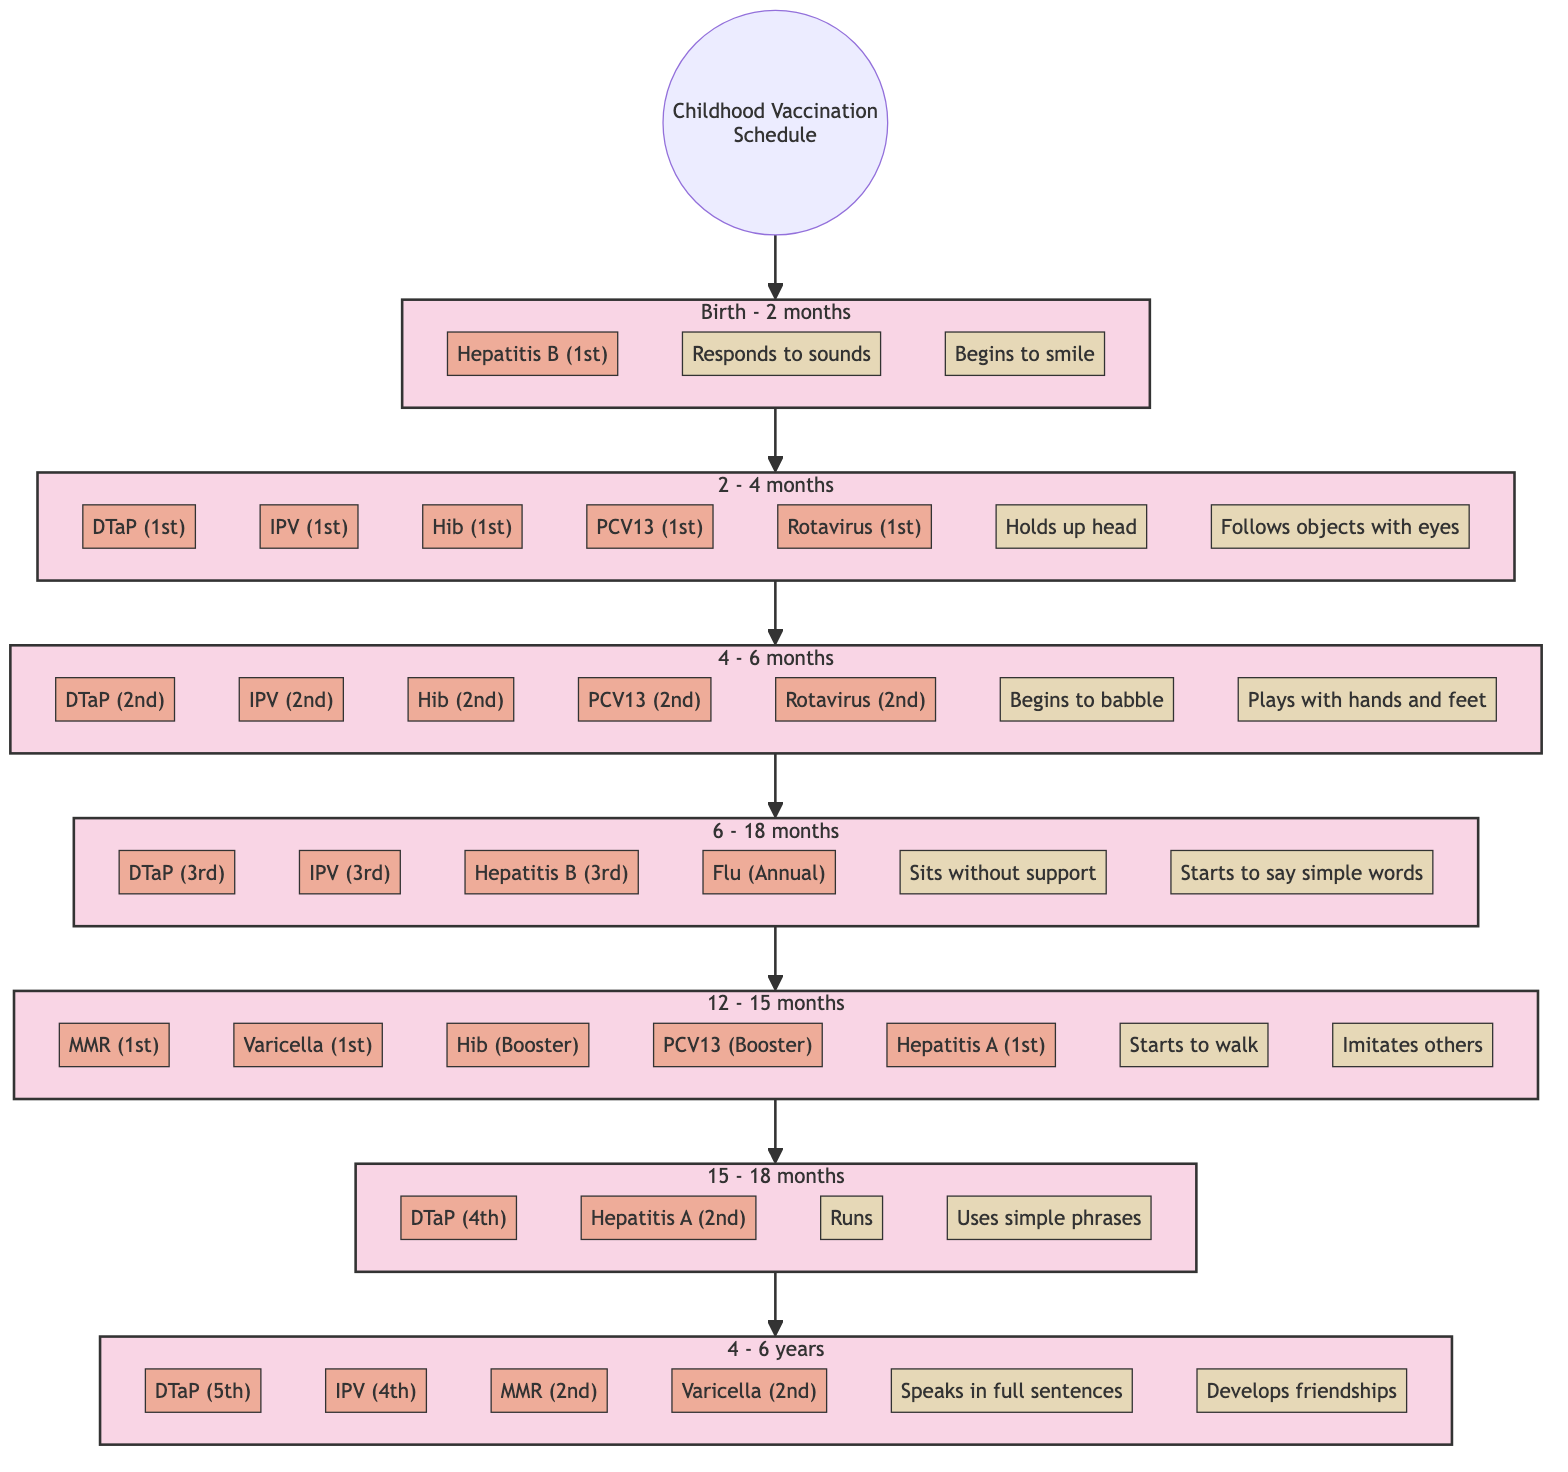What's the first vaccination listed for the age range Birth - 2 months? The diagram shows the "Hepatitis B" vaccination as the first vaccination under the age range Birth - 2 months.
Answer: Hepatitis B How many vaccinations are listed for the 2 months - 4 months age range? In the diagram, there are five vaccinations listed for the age range of 2 months - 4 months: DTaP, IPV, Hib, PCV13, and Rotavirus.
Answer: 5 What milestone is reached at 12 - 15 months? The diagram indicates two milestones are reached at this age: "Starts to walk" and "Imitates others". The answer is based on identifying both milestones listed.
Answer: Starts to walk What is the last age group mentioned in the diagram? The last age group shown is "4 - 6 years." This can be confirmed by tracing the flow from the Start to the last subgraph in the diagram.
Answer: 4 - 6 years How many doses of DTaP are administered by the age of 18 months? Analyzing the DTaP vaccinations needed by 18 months, the diagram shows 4 doses: 1st dose (2 - 4 months), 2nd dose (4 - 6 months), 3rd dose (6 - 18 months), and 4th dose (15 - 18 months). Adding these gives a total of four DTaP doses by 18 months.
Answer: 4 Which vaccination is administered at 15 - 18 months for Hepatitis A? The diagram shows that the "Hepatitis A" vaccination is administered as the 2nd dose at the age range of 15 - 18 months.
Answer: 2nd dose What are two milestones reached at the age range 4 - 6 years? The diagram lists two milestones for this age range: "Speaks in full sentences" and "Develops friendships." Both milestones can be found in the corresponding subgraph.
Answer: Speaks in full sentences, Develops friendships List the vaccinations given at 12 - 15 months. The vaccinations given at this age range according to the diagram are MMR (1st), Varicella (1st), Hib (Booster), PCV13 (Booster), and Hepatitis A (1st).
Answer: MMR, Varicella, Hib, PCV13, Hepatitis A What is the required vaccination type for Flu in the age range of 6 - 18 months? The diagram specifies the Flu as "Annual" vaccination in the age range of 6 - 18 months, indicating it is an annual requirement within that period.
Answer: Annual 